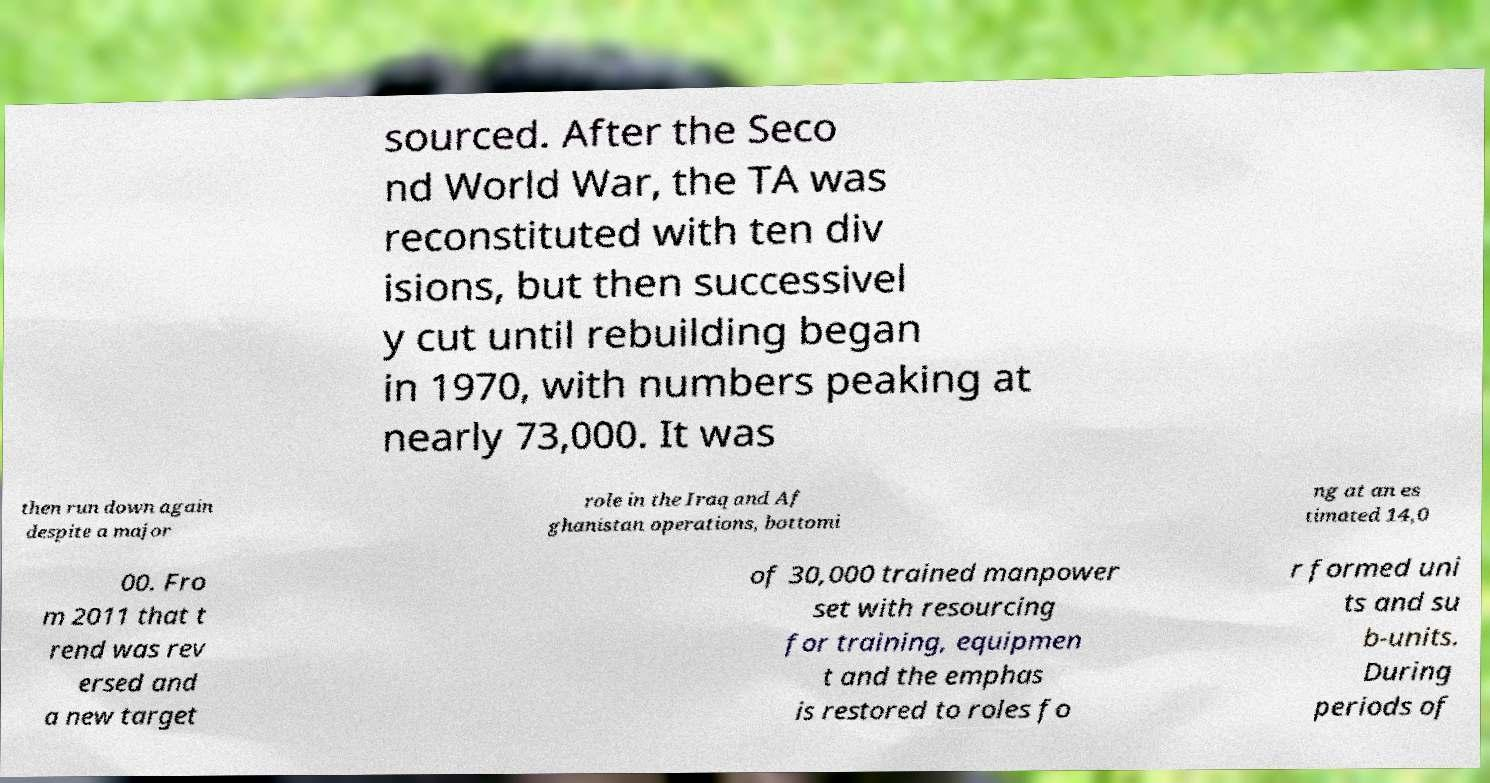What messages or text are displayed in this image? I need them in a readable, typed format. sourced. After the Seco nd World War, the TA was reconstituted with ten div isions, but then successivel y cut until rebuilding began in 1970, with numbers peaking at nearly 73,000. It was then run down again despite a major role in the Iraq and Af ghanistan operations, bottomi ng at an es timated 14,0 00. Fro m 2011 that t rend was rev ersed and a new target of 30,000 trained manpower set with resourcing for training, equipmen t and the emphas is restored to roles fo r formed uni ts and su b-units. During periods of 